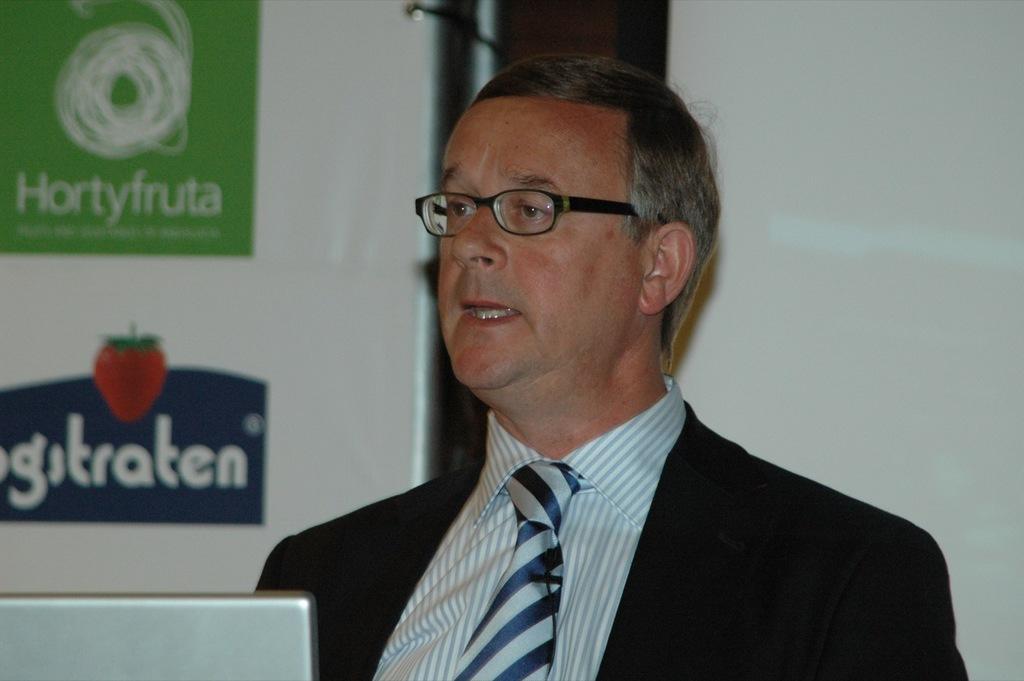Please provide a concise description of this image. In this picture we can see a man in the black blazer. In front of the man it looks like a laptop. Behind the man there is a board and a projector screen. 